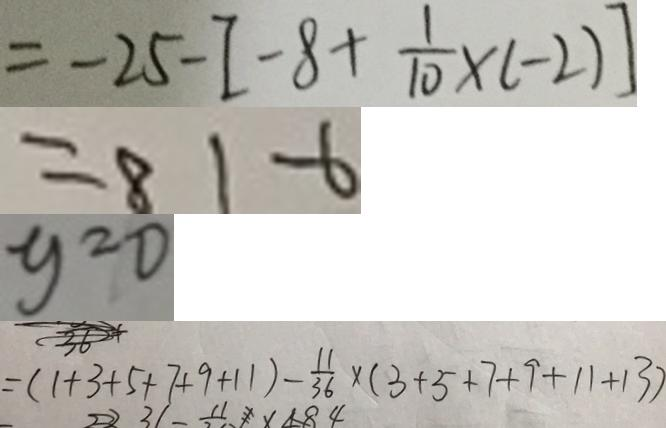<formula> <loc_0><loc_0><loc_500><loc_500>= - 2 5 - [ - 8 + \frac { 1 } { 1 0 } \times ( - 2 ) ] 
 = 8 1 - 6 
 y = 0 
 = ( 1 + 3 + 5 + 7 + 9 + 1 1 ) - \frac { 1 1 } { 3 6 } \times ( 3 + 5 + 7 + 9 + 1 1 + 1 3 )</formula> 